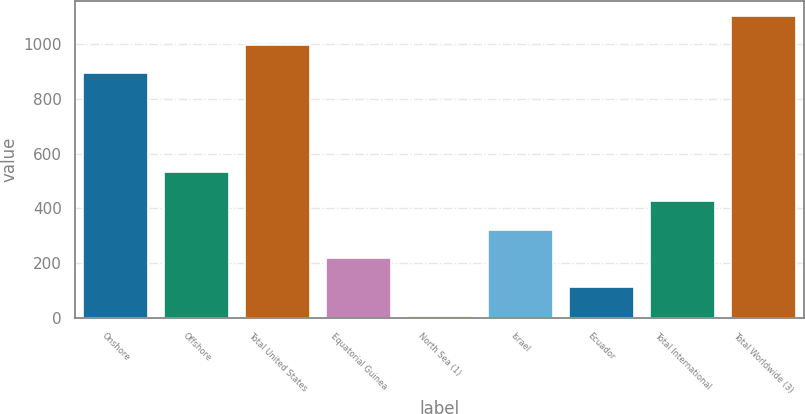Convert chart. <chart><loc_0><loc_0><loc_500><loc_500><bar_chart><fcel>Onshore<fcel>Offshore<fcel>Total United States<fcel>Equatorial Guinea<fcel>North Sea (1)<fcel>Israel<fcel>Ecuador<fcel>Total International<fcel>Total Worldwide (3)<nl><fcel>893<fcel>534<fcel>998.6<fcel>217.2<fcel>6<fcel>322.8<fcel>111.6<fcel>428.4<fcel>1104.2<nl></chart> 